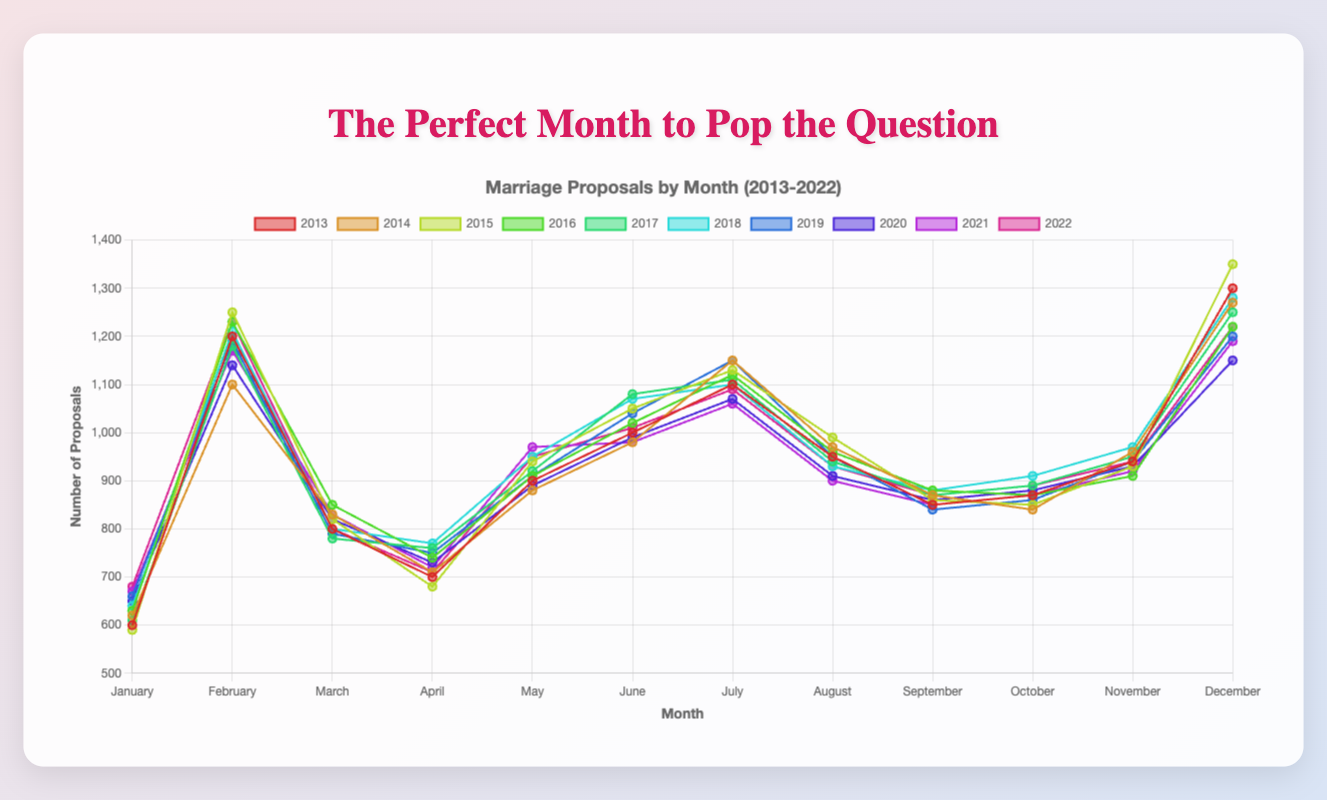When is the peak month for marriage proposals? The peak can be determined by identifying which month has the highest number of proposals over the last ten years. From the figure, it can be observed that "December" consistently has the highest number of proposals in each year.
Answer: December Which month has the lowest average number of marriage proposals? To find the month with the lowest average, sum up the number of proposals in each month for all years, and then divide by 10 (since there are 10 years of data). The month with the lowest average gives us the answer.
Answer: January How do February and December compare in the number of proposals over the years? Compare the data points for February and December across each year. Generally, December has more proposals compared to February, making it more popular for proposals.
Answer: December has more Visually, which year has the most consistent trend across all months in terms of proposal rates? Look for a year where the line representing that year on the chart shows the least fluctuation (i.e., the line is less jagged). This indicates a consistent trend over the months.
Answer: 2019 What is the average number of proposals in June over the decade? Sum the proposal numbers for June across all years and divide by the number of years (10). Calculation: (1000 + 980 + 1050 + 1020 + 1080 + 1070 + 1040 + 990 + 980 + 1010) / 10.
Answer: 1022 Which year had the highest number of proposals in February, and how many were there? To find this, identify the year with the highest data point for February from the chart. The highest number of proposals in February occurs in 2015 with 1250 proposals.
Answer: 2015, 1250 What is the range in the number of proposals for November over the ten years? Identify the maximum and minimum number of proposals in November from the figure. The range is the difference between the maximum and minimum values.
Answer: 970 - 910 = 60 Between April and August, in which month do proposals generally increase more consistently each year? Compare the trends between April and August for each year. August generally shows a more consistent increase in proposals compared to April.
Answer: August By how much did the number of proposals in February 2022 increase compared to February 2013? Subtract the number of proposals in February 2013 from February 2022. Calculation: 1230 - 1200 = 30.
Answer: 30 In which year was the total number of proposals for the entire year the highest, and what was the total? Sum the total number of proposals for each year and compare. Calculation involves summing all monthly data points and finding the year with the highest sum.
Answer: 2015, 12700 